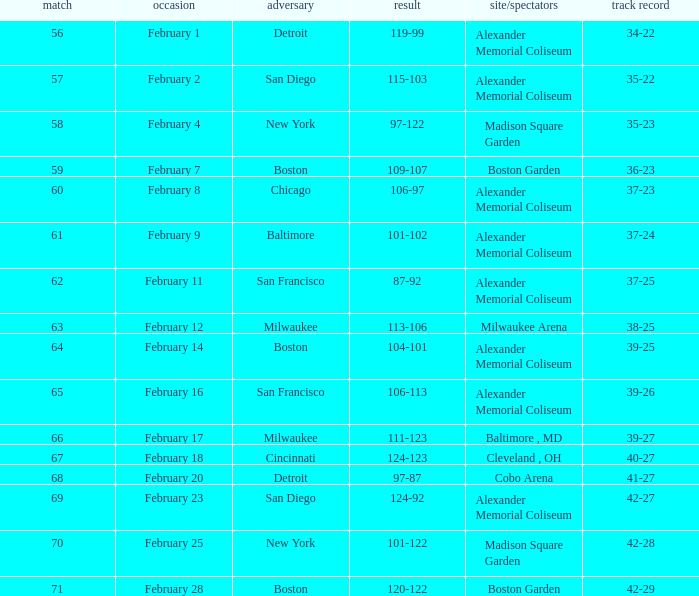What is the Game # that scored 87-92? 62.0. 